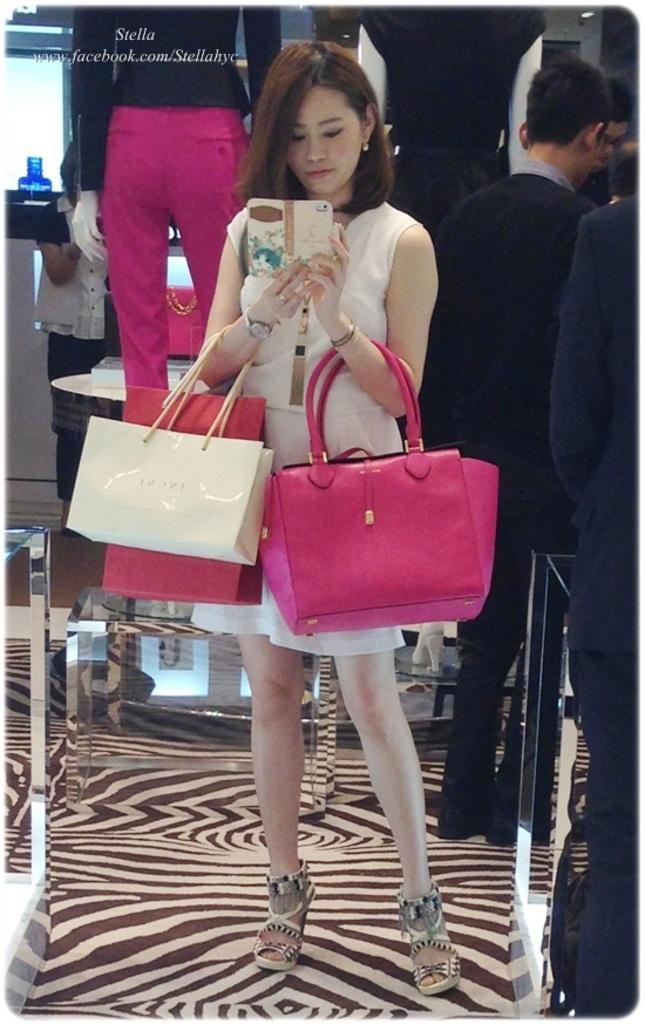In one or two sentences, can you explain what this image depicts? As we can see in the image there are few people standing over here and the women who is standing here is holding mobile phone and handbags. 